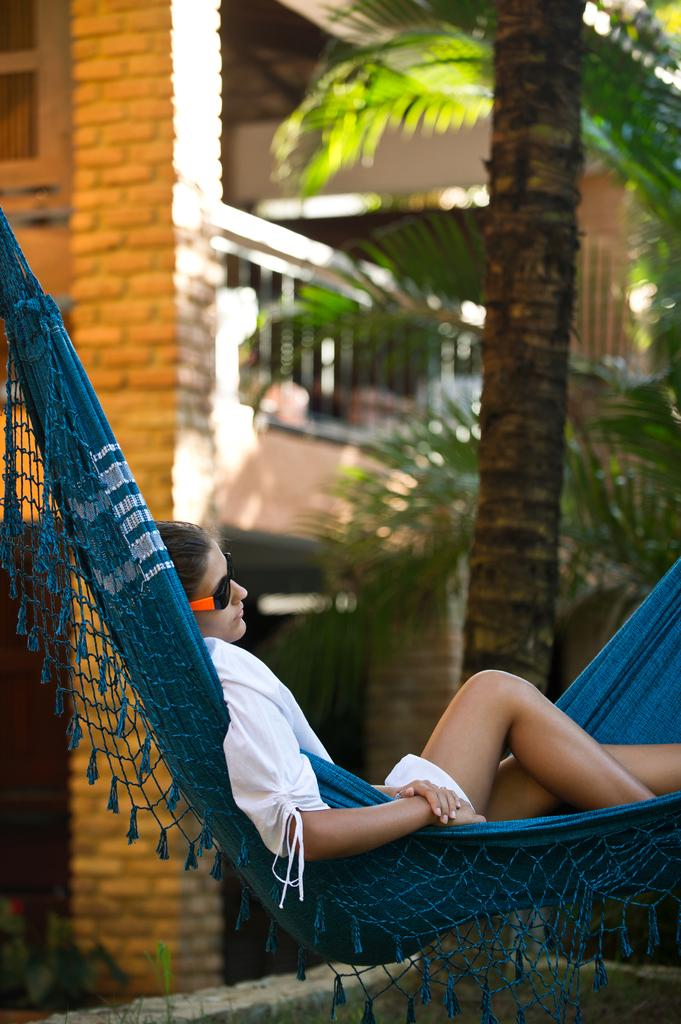What is the main subject in the center of the image? There is a woman in a swing in the center of the image. What can be seen in the background of the image? There are trees and a building in the background of the image. What type of surface is visible at the bottom of the image? Grass is present at the bottom of the image. What type of zipper can be seen on the woman's clothing in the image? There is no zipper visible on the woman's clothing in the image. How many bananas are being held by the woman in the image? There are no bananas present in the image. 